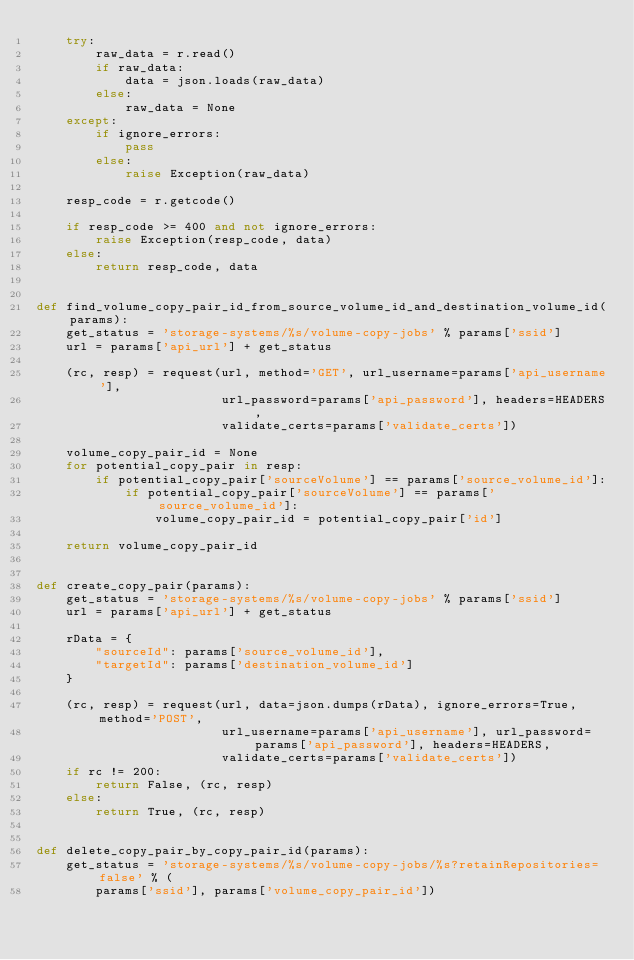<code> <loc_0><loc_0><loc_500><loc_500><_Python_>    try:
        raw_data = r.read()
        if raw_data:
            data = json.loads(raw_data)
        else:
            raw_data = None
    except:
        if ignore_errors:
            pass
        else:
            raise Exception(raw_data)

    resp_code = r.getcode()

    if resp_code >= 400 and not ignore_errors:
        raise Exception(resp_code, data)
    else:
        return resp_code, data


def find_volume_copy_pair_id_from_source_volume_id_and_destination_volume_id(params):
    get_status = 'storage-systems/%s/volume-copy-jobs' % params['ssid']
    url = params['api_url'] + get_status

    (rc, resp) = request(url, method='GET', url_username=params['api_username'],
                         url_password=params['api_password'], headers=HEADERS,
                         validate_certs=params['validate_certs'])

    volume_copy_pair_id = None
    for potential_copy_pair in resp:
        if potential_copy_pair['sourceVolume'] == params['source_volume_id']:
            if potential_copy_pair['sourceVolume'] == params['source_volume_id']:
                volume_copy_pair_id = potential_copy_pair['id']

    return volume_copy_pair_id


def create_copy_pair(params):
    get_status = 'storage-systems/%s/volume-copy-jobs' % params['ssid']
    url = params['api_url'] + get_status

    rData = {
        "sourceId": params['source_volume_id'],
        "targetId": params['destination_volume_id']
    }

    (rc, resp) = request(url, data=json.dumps(rData), ignore_errors=True, method='POST',
                         url_username=params['api_username'], url_password=params['api_password'], headers=HEADERS,
                         validate_certs=params['validate_certs'])
    if rc != 200:
        return False, (rc, resp)
    else:
        return True, (rc, resp)


def delete_copy_pair_by_copy_pair_id(params):
    get_status = 'storage-systems/%s/volume-copy-jobs/%s?retainRepositories=false' % (
        params['ssid'], params['volume_copy_pair_id'])</code> 